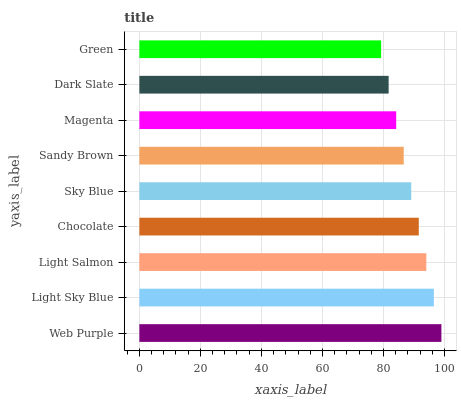Is Green the minimum?
Answer yes or no. Yes. Is Web Purple the maximum?
Answer yes or no. Yes. Is Light Sky Blue the minimum?
Answer yes or no. No. Is Light Sky Blue the maximum?
Answer yes or no. No. Is Web Purple greater than Light Sky Blue?
Answer yes or no. Yes. Is Light Sky Blue less than Web Purple?
Answer yes or no. Yes. Is Light Sky Blue greater than Web Purple?
Answer yes or no. No. Is Web Purple less than Light Sky Blue?
Answer yes or no. No. Is Sky Blue the high median?
Answer yes or no. Yes. Is Sky Blue the low median?
Answer yes or no. Yes. Is Green the high median?
Answer yes or no. No. Is Green the low median?
Answer yes or no. No. 